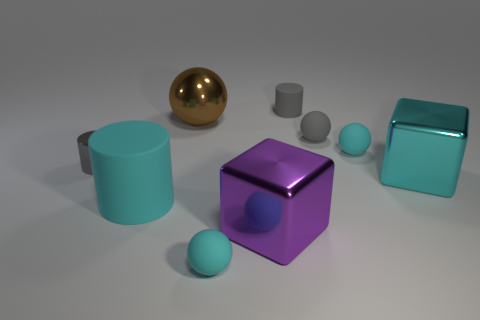Subtract 2 balls. How many balls are left? 2 Subtract all green balls. Subtract all purple cylinders. How many balls are left? 4 Add 1 big balls. How many objects exist? 10 Subtract all balls. How many objects are left? 5 Add 5 big brown metallic balls. How many big brown metallic balls are left? 6 Add 7 red metallic objects. How many red metallic objects exist? 7 Subtract 0 green cylinders. How many objects are left? 9 Subtract all matte cylinders. Subtract all large gray objects. How many objects are left? 7 